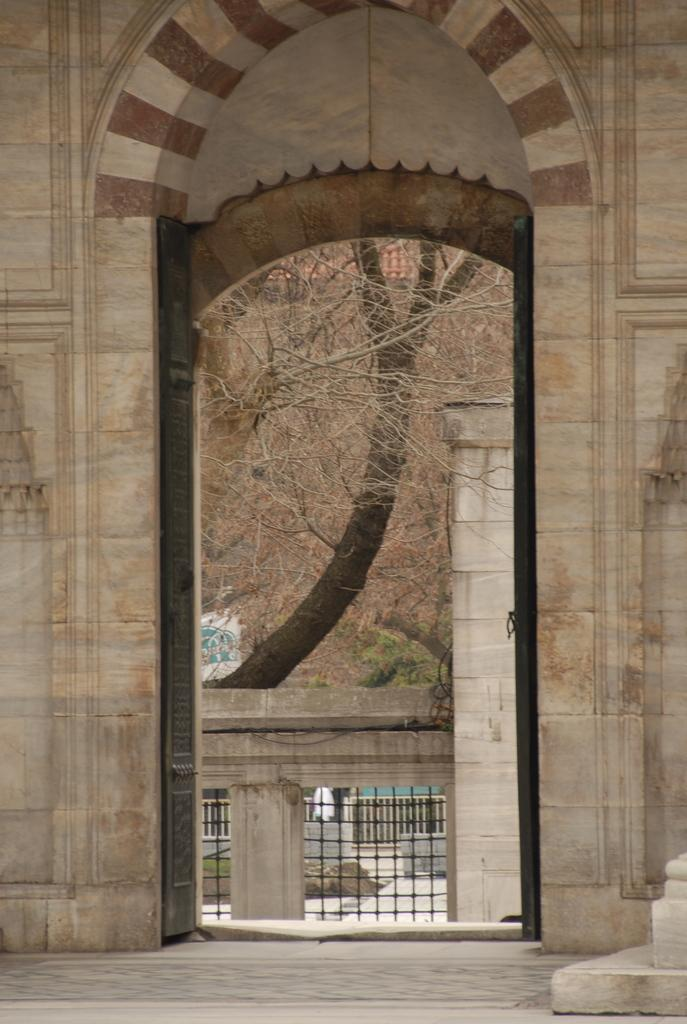What type of structure is visible in the image? There is an entrance with an arch in the image. What can be seen through the entrance? Trees are visible through the entrance. What feature is present to provide support or safety? There is a railing in the image. What surrounds the entrance on the sides? There are walls on the sides of the entrance. What type of fuel is being used to teach the class in the image? There is no class or fuel present in the image; it features an entrance with an arch, trees, a railing, and walls. 